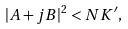<formula> <loc_0><loc_0><loc_500><loc_500>| A + j B | ^ { 2 } < N K ^ { \prime } ,</formula> 